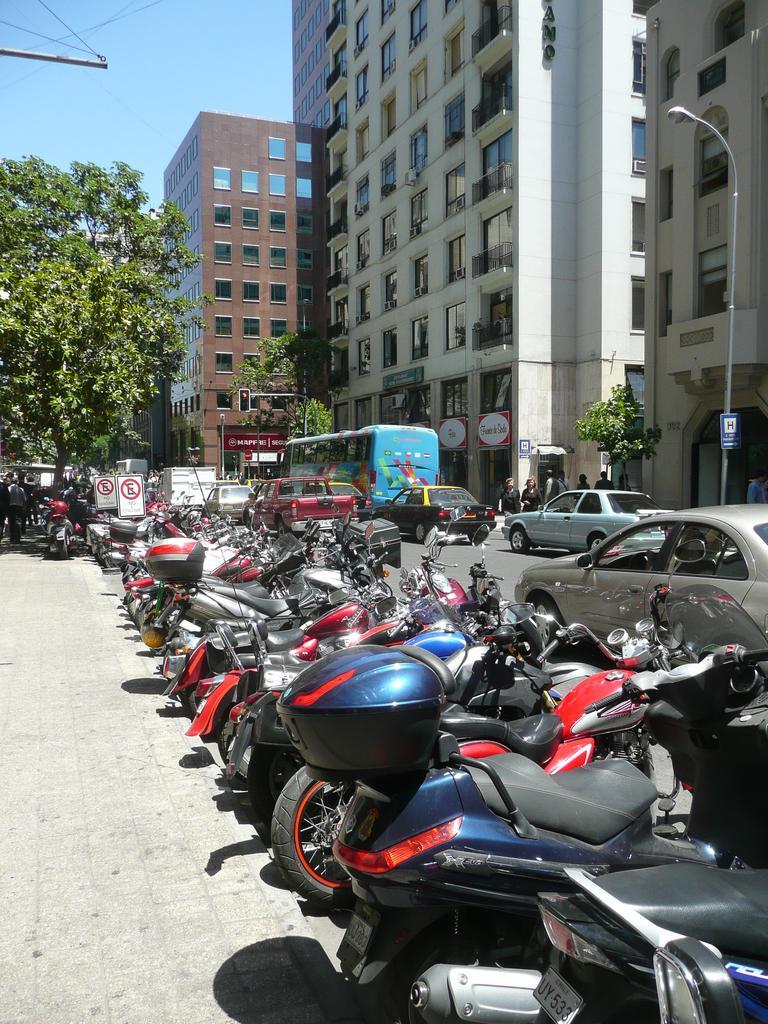Could you give a brief overview of what you see in this image? In this image there are bikes on the pavement. There are boards attached to the poles. Left side there are people walking on the pavement. There are vehicles on the road. Right side there are people on the pavement having trees. There is a board attached to a street light. Background there are trees and buildings. Left top there is sky. There is a traffic light attached to the pole. 